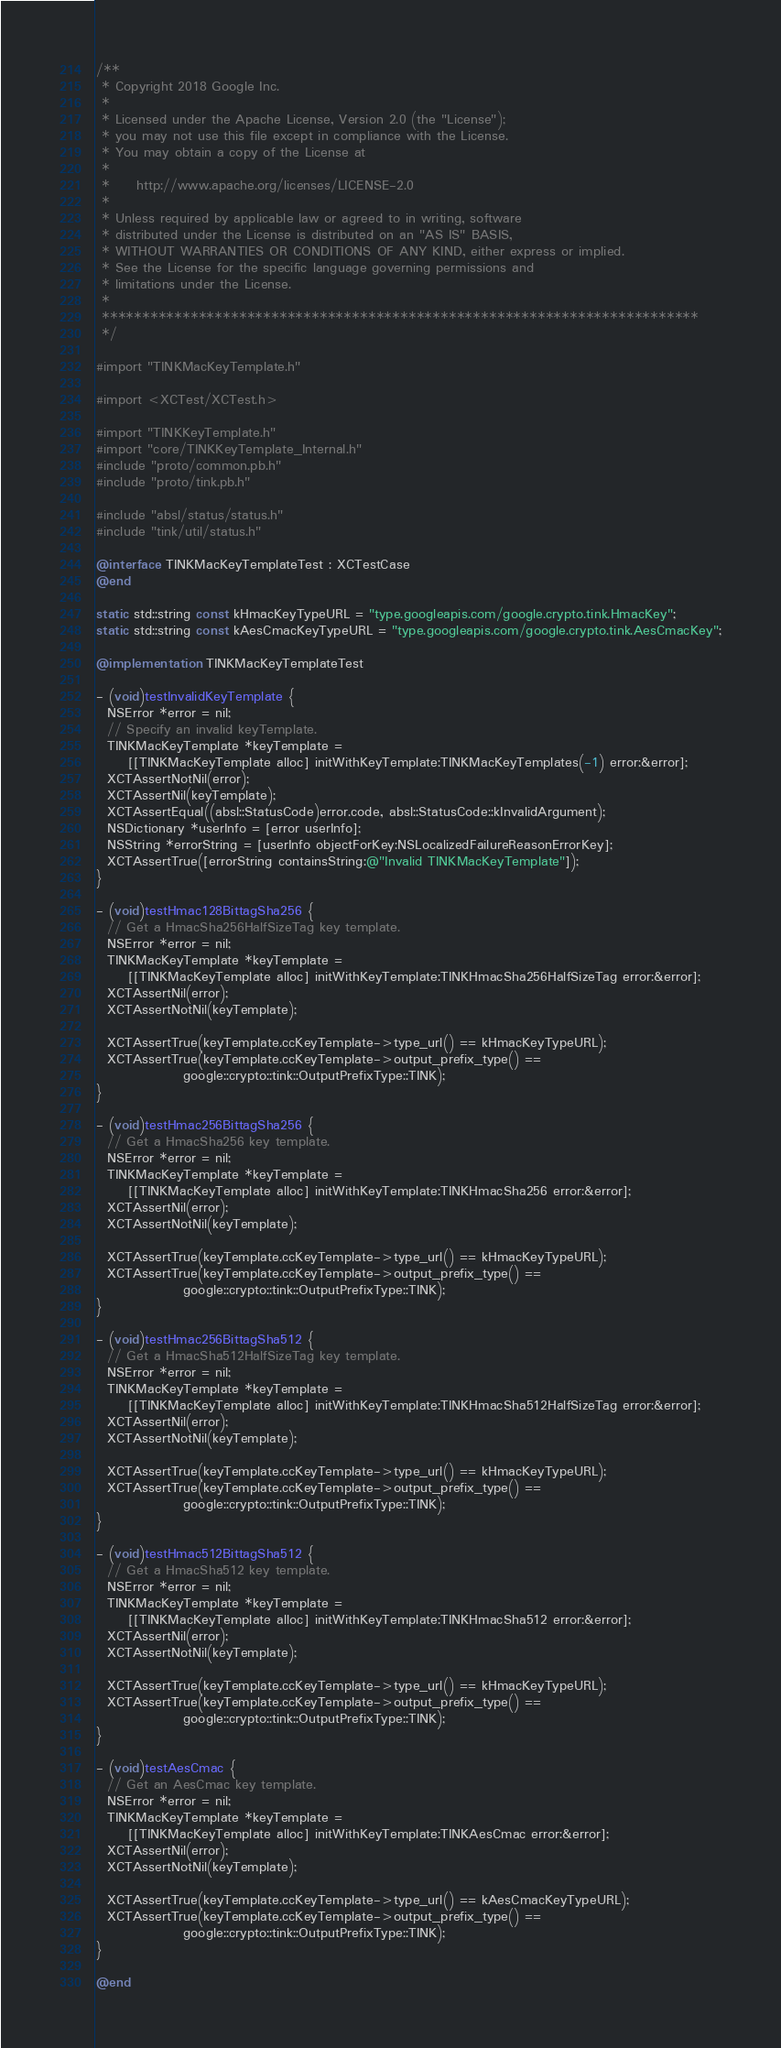<code> <loc_0><loc_0><loc_500><loc_500><_ObjectiveC_>/**
 * Copyright 2018 Google Inc.
 *
 * Licensed under the Apache License, Version 2.0 (the "License");
 * you may not use this file except in compliance with the License.
 * You may obtain a copy of the License at
 *
 *     http://www.apache.org/licenses/LICENSE-2.0
 *
 * Unless required by applicable law or agreed to in writing, software
 * distributed under the License is distributed on an "AS IS" BASIS,
 * WITHOUT WARRANTIES OR CONDITIONS OF ANY KIND, either express or implied.
 * See the License for the specific language governing permissions and
 * limitations under the License.
 *
 **************************************************************************
 */

#import "TINKMacKeyTemplate.h"

#import <XCTest/XCTest.h>

#import "TINKKeyTemplate.h"
#import "core/TINKKeyTemplate_Internal.h"
#include "proto/common.pb.h"
#include "proto/tink.pb.h"

#include "absl/status/status.h"
#include "tink/util/status.h"

@interface TINKMacKeyTemplateTest : XCTestCase
@end

static std::string const kHmacKeyTypeURL = "type.googleapis.com/google.crypto.tink.HmacKey";
static std::string const kAesCmacKeyTypeURL = "type.googleapis.com/google.crypto.tink.AesCmacKey";

@implementation TINKMacKeyTemplateTest

- (void)testInvalidKeyTemplate {
  NSError *error = nil;
  // Specify an invalid keyTemplate.
  TINKMacKeyTemplate *keyTemplate =
      [[TINKMacKeyTemplate alloc] initWithKeyTemplate:TINKMacKeyTemplates(-1) error:&error];
  XCTAssertNotNil(error);
  XCTAssertNil(keyTemplate);
  XCTAssertEqual((absl::StatusCode)error.code, absl::StatusCode::kInvalidArgument);
  NSDictionary *userInfo = [error userInfo];
  NSString *errorString = [userInfo objectForKey:NSLocalizedFailureReasonErrorKey];
  XCTAssertTrue([errorString containsString:@"Invalid TINKMacKeyTemplate"]);
}

- (void)testHmac128BittagSha256 {
  // Get a HmacSha256HalfSizeTag key template.
  NSError *error = nil;
  TINKMacKeyTemplate *keyTemplate =
      [[TINKMacKeyTemplate alloc] initWithKeyTemplate:TINKHmacSha256HalfSizeTag error:&error];
  XCTAssertNil(error);
  XCTAssertNotNil(keyTemplate);

  XCTAssertTrue(keyTemplate.ccKeyTemplate->type_url() == kHmacKeyTypeURL);
  XCTAssertTrue(keyTemplate.ccKeyTemplate->output_prefix_type() ==
                google::crypto::tink::OutputPrefixType::TINK);
}

- (void)testHmac256BittagSha256 {
  // Get a HmacSha256 key template.
  NSError *error = nil;
  TINKMacKeyTemplate *keyTemplate =
      [[TINKMacKeyTemplate alloc] initWithKeyTemplate:TINKHmacSha256 error:&error];
  XCTAssertNil(error);
  XCTAssertNotNil(keyTemplate);

  XCTAssertTrue(keyTemplate.ccKeyTemplate->type_url() == kHmacKeyTypeURL);
  XCTAssertTrue(keyTemplate.ccKeyTemplate->output_prefix_type() ==
                google::crypto::tink::OutputPrefixType::TINK);
}

- (void)testHmac256BittagSha512 {
  // Get a HmacSha512HalfSizeTag key template.
  NSError *error = nil;
  TINKMacKeyTemplate *keyTemplate =
      [[TINKMacKeyTemplate alloc] initWithKeyTemplate:TINKHmacSha512HalfSizeTag error:&error];
  XCTAssertNil(error);
  XCTAssertNotNil(keyTemplate);

  XCTAssertTrue(keyTemplate.ccKeyTemplate->type_url() == kHmacKeyTypeURL);
  XCTAssertTrue(keyTemplate.ccKeyTemplate->output_prefix_type() ==
                google::crypto::tink::OutputPrefixType::TINK);
}

- (void)testHmac512BittagSha512 {
  // Get a HmacSha512 key template.
  NSError *error = nil;
  TINKMacKeyTemplate *keyTemplate =
      [[TINKMacKeyTemplate alloc] initWithKeyTemplate:TINKHmacSha512 error:&error];
  XCTAssertNil(error);
  XCTAssertNotNil(keyTemplate);

  XCTAssertTrue(keyTemplate.ccKeyTemplate->type_url() == kHmacKeyTypeURL);
  XCTAssertTrue(keyTemplate.ccKeyTemplate->output_prefix_type() ==
                google::crypto::tink::OutputPrefixType::TINK);
}

- (void)testAesCmac {
  // Get an AesCmac key template.
  NSError *error = nil;
  TINKMacKeyTemplate *keyTemplate =
      [[TINKMacKeyTemplate alloc] initWithKeyTemplate:TINKAesCmac error:&error];
  XCTAssertNil(error);
  XCTAssertNotNil(keyTemplate);

  XCTAssertTrue(keyTemplate.ccKeyTemplate->type_url() == kAesCmacKeyTypeURL);
  XCTAssertTrue(keyTemplate.ccKeyTemplate->output_prefix_type() ==
                google::crypto::tink::OutputPrefixType::TINK);
}

@end
</code> 